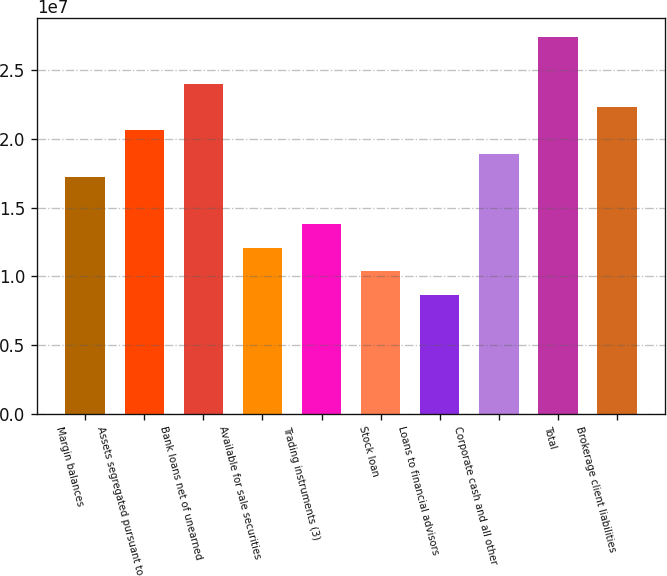<chart> <loc_0><loc_0><loc_500><loc_500><bar_chart><fcel>Margin balances<fcel>Assets segregated pursuant to<fcel>Bank loans net of unearned<fcel>Available for sale securities<fcel>Trading instruments (3)<fcel>Stock loan<fcel>Loans to financial advisors<fcel>Corporate cash and all other<fcel>Total<fcel>Brokerage client liabilities<nl><fcel>1.71929e+07<fcel>2.06138e+07<fcel>2.40346e+07<fcel>1.20617e+07<fcel>1.37721e+07<fcel>1.03513e+07<fcel>8.64085e+06<fcel>1.89034e+07<fcel>2.74554e+07<fcel>2.23242e+07<nl></chart> 